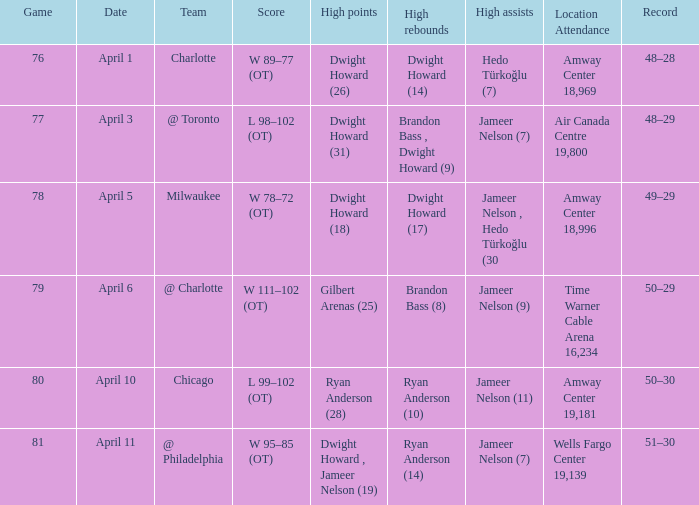Who secured the most rebounds on april 1, and what was their total amount? Dwight Howard (14). 